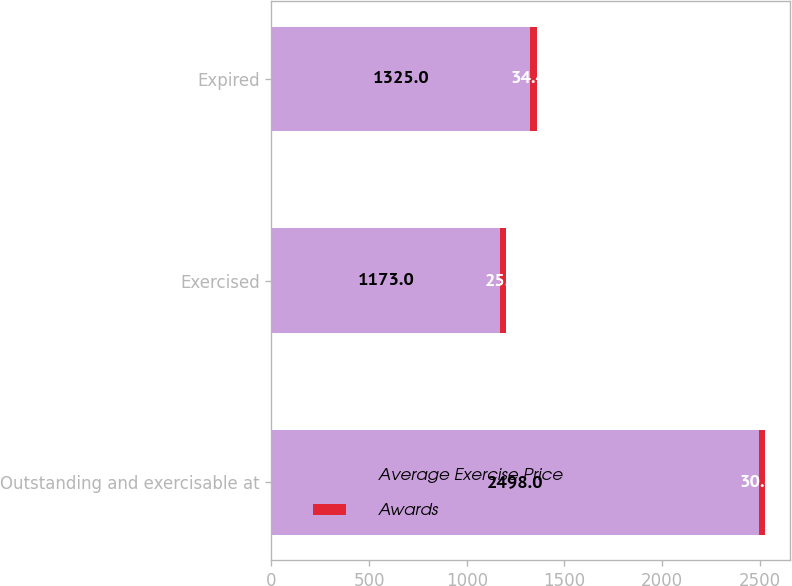Convert chart. <chart><loc_0><loc_0><loc_500><loc_500><stacked_bar_chart><ecel><fcel>Outstanding and exercisable at<fcel>Exercised<fcel>Expired<nl><fcel>Average Exercise Price<fcel>2498<fcel>1173<fcel>1325<nl><fcel>Awards<fcel>30.42<fcel>25.9<fcel>34.42<nl></chart> 